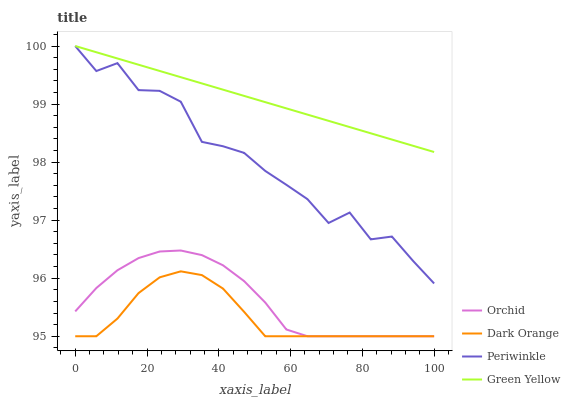Does Dark Orange have the minimum area under the curve?
Answer yes or no. Yes. Does Green Yellow have the maximum area under the curve?
Answer yes or no. Yes. Does Periwinkle have the minimum area under the curve?
Answer yes or no. No. Does Periwinkle have the maximum area under the curve?
Answer yes or no. No. Is Green Yellow the smoothest?
Answer yes or no. Yes. Is Periwinkle the roughest?
Answer yes or no. Yes. Is Periwinkle the smoothest?
Answer yes or no. No. Is Green Yellow the roughest?
Answer yes or no. No. Does Dark Orange have the lowest value?
Answer yes or no. Yes. Does Periwinkle have the lowest value?
Answer yes or no. No. Does Periwinkle have the highest value?
Answer yes or no. Yes. Does Orchid have the highest value?
Answer yes or no. No. Is Dark Orange less than Periwinkle?
Answer yes or no. Yes. Is Periwinkle greater than Orchid?
Answer yes or no. Yes. Does Orchid intersect Dark Orange?
Answer yes or no. Yes. Is Orchid less than Dark Orange?
Answer yes or no. No. Is Orchid greater than Dark Orange?
Answer yes or no. No. Does Dark Orange intersect Periwinkle?
Answer yes or no. No. 